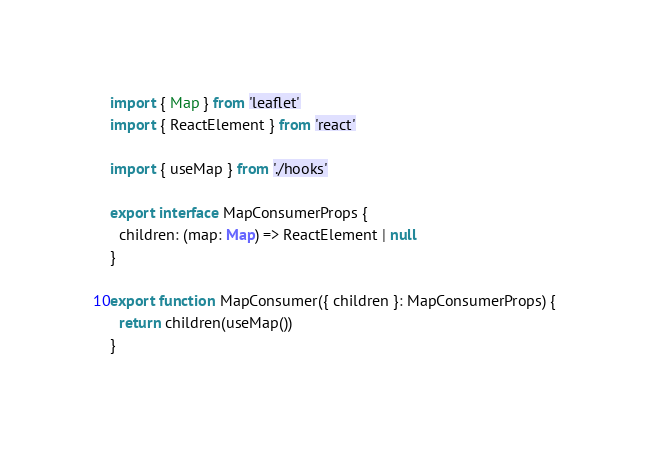<code> <loc_0><loc_0><loc_500><loc_500><_TypeScript_>import { Map } from 'leaflet'
import { ReactElement } from 'react'

import { useMap } from './hooks'

export interface MapConsumerProps {
  children: (map: Map) => ReactElement | null
}

export function MapConsumer({ children }: MapConsumerProps) {
  return children(useMap())
}
</code> 